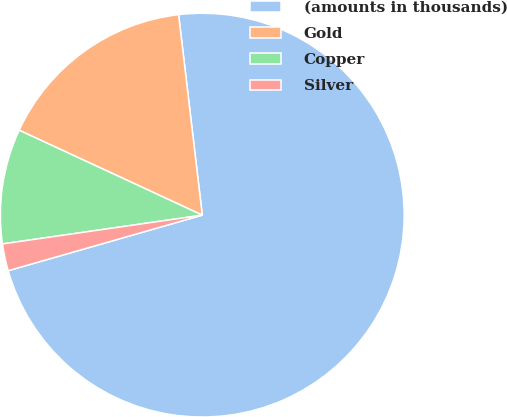Convert chart to OTSL. <chart><loc_0><loc_0><loc_500><loc_500><pie_chart><fcel>(amounts in thousands)<fcel>Gold<fcel>Copper<fcel>Silver<nl><fcel>72.44%<fcel>16.22%<fcel>9.19%<fcel>2.16%<nl></chart> 